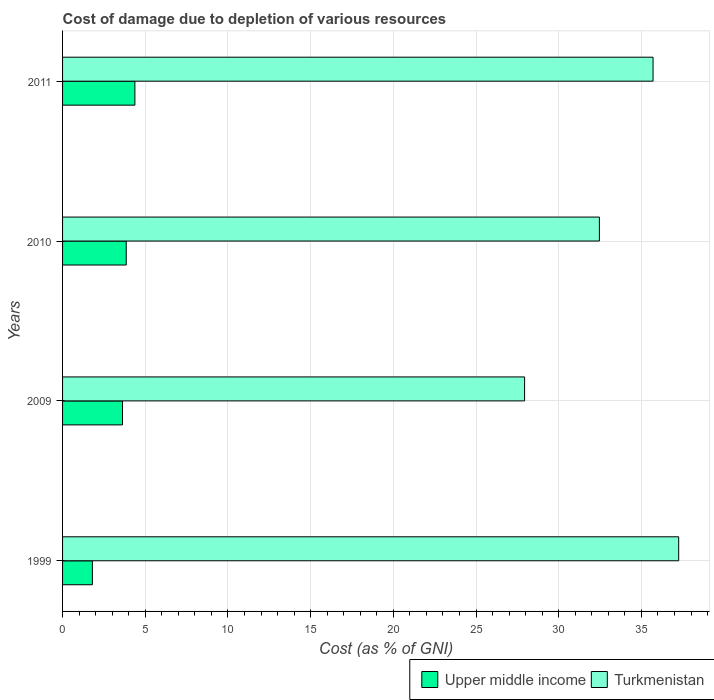How many different coloured bars are there?
Provide a short and direct response. 2. Are the number of bars on each tick of the Y-axis equal?
Give a very brief answer. Yes. How many bars are there on the 4th tick from the top?
Your answer should be very brief. 2. What is the label of the 1st group of bars from the top?
Your response must be concise. 2011. In how many cases, is the number of bars for a given year not equal to the number of legend labels?
Ensure brevity in your answer.  0. What is the cost of damage caused due to the depletion of various resources in Turkmenistan in 2011?
Keep it short and to the point. 35.7. Across all years, what is the maximum cost of damage caused due to the depletion of various resources in Upper middle income?
Provide a short and direct response. 4.37. Across all years, what is the minimum cost of damage caused due to the depletion of various resources in Upper middle income?
Make the answer very short. 1.8. In which year was the cost of damage caused due to the depletion of various resources in Upper middle income maximum?
Give a very brief answer. 2011. In which year was the cost of damage caused due to the depletion of various resources in Upper middle income minimum?
Keep it short and to the point. 1999. What is the total cost of damage caused due to the depletion of various resources in Upper middle income in the graph?
Offer a terse response. 13.65. What is the difference between the cost of damage caused due to the depletion of various resources in Turkmenistan in 2010 and that in 2011?
Provide a short and direct response. -3.24. What is the difference between the cost of damage caused due to the depletion of various resources in Turkmenistan in 2011 and the cost of damage caused due to the depletion of various resources in Upper middle income in 1999?
Ensure brevity in your answer.  33.9. What is the average cost of damage caused due to the depletion of various resources in Upper middle income per year?
Provide a succinct answer. 3.41. In the year 1999, what is the difference between the cost of damage caused due to the depletion of various resources in Turkmenistan and cost of damage caused due to the depletion of various resources in Upper middle income?
Offer a terse response. 35.45. In how many years, is the cost of damage caused due to the depletion of various resources in Upper middle income greater than 3 %?
Give a very brief answer. 3. What is the ratio of the cost of damage caused due to the depletion of various resources in Turkmenistan in 1999 to that in 2010?
Your response must be concise. 1.15. Is the cost of damage caused due to the depletion of various resources in Upper middle income in 2009 less than that in 2011?
Offer a very short reply. Yes. Is the difference between the cost of damage caused due to the depletion of various resources in Turkmenistan in 2009 and 2010 greater than the difference between the cost of damage caused due to the depletion of various resources in Upper middle income in 2009 and 2010?
Provide a short and direct response. No. What is the difference between the highest and the second highest cost of damage caused due to the depletion of various resources in Upper middle income?
Offer a very short reply. 0.52. What is the difference between the highest and the lowest cost of damage caused due to the depletion of various resources in Upper middle income?
Your answer should be very brief. 2.57. Is the sum of the cost of damage caused due to the depletion of various resources in Turkmenistan in 1999 and 2011 greater than the maximum cost of damage caused due to the depletion of various resources in Upper middle income across all years?
Make the answer very short. Yes. What does the 2nd bar from the top in 2009 represents?
Offer a very short reply. Upper middle income. What does the 1st bar from the bottom in 2009 represents?
Your response must be concise. Upper middle income. Are all the bars in the graph horizontal?
Make the answer very short. Yes. How many years are there in the graph?
Your response must be concise. 4. What is the difference between two consecutive major ticks on the X-axis?
Your answer should be very brief. 5. Does the graph contain grids?
Make the answer very short. Yes. Where does the legend appear in the graph?
Provide a short and direct response. Bottom right. How many legend labels are there?
Provide a succinct answer. 2. How are the legend labels stacked?
Offer a terse response. Horizontal. What is the title of the graph?
Your answer should be compact. Cost of damage due to depletion of various resources. Does "Angola" appear as one of the legend labels in the graph?
Provide a succinct answer. No. What is the label or title of the X-axis?
Your answer should be very brief. Cost (as % of GNI). What is the label or title of the Y-axis?
Your answer should be very brief. Years. What is the Cost (as % of GNI) of Upper middle income in 1999?
Ensure brevity in your answer.  1.8. What is the Cost (as % of GNI) of Turkmenistan in 1999?
Your answer should be compact. 37.25. What is the Cost (as % of GNI) in Upper middle income in 2009?
Your answer should be compact. 3.62. What is the Cost (as % of GNI) of Turkmenistan in 2009?
Your answer should be compact. 27.94. What is the Cost (as % of GNI) in Upper middle income in 2010?
Your response must be concise. 3.85. What is the Cost (as % of GNI) in Turkmenistan in 2010?
Give a very brief answer. 32.46. What is the Cost (as % of GNI) in Upper middle income in 2011?
Offer a terse response. 4.37. What is the Cost (as % of GNI) in Turkmenistan in 2011?
Your answer should be very brief. 35.7. Across all years, what is the maximum Cost (as % of GNI) of Upper middle income?
Give a very brief answer. 4.37. Across all years, what is the maximum Cost (as % of GNI) in Turkmenistan?
Provide a short and direct response. 37.25. Across all years, what is the minimum Cost (as % of GNI) in Upper middle income?
Your response must be concise. 1.8. Across all years, what is the minimum Cost (as % of GNI) of Turkmenistan?
Make the answer very short. 27.94. What is the total Cost (as % of GNI) in Upper middle income in the graph?
Make the answer very short. 13.65. What is the total Cost (as % of GNI) of Turkmenistan in the graph?
Your response must be concise. 133.35. What is the difference between the Cost (as % of GNI) of Upper middle income in 1999 and that in 2009?
Offer a very short reply. -1.82. What is the difference between the Cost (as % of GNI) in Turkmenistan in 1999 and that in 2009?
Your response must be concise. 9.32. What is the difference between the Cost (as % of GNI) in Upper middle income in 1999 and that in 2010?
Ensure brevity in your answer.  -2.05. What is the difference between the Cost (as % of GNI) of Turkmenistan in 1999 and that in 2010?
Your response must be concise. 4.79. What is the difference between the Cost (as % of GNI) of Upper middle income in 1999 and that in 2011?
Your answer should be compact. -2.57. What is the difference between the Cost (as % of GNI) of Turkmenistan in 1999 and that in 2011?
Give a very brief answer. 1.55. What is the difference between the Cost (as % of GNI) of Upper middle income in 2009 and that in 2010?
Make the answer very short. -0.22. What is the difference between the Cost (as % of GNI) in Turkmenistan in 2009 and that in 2010?
Make the answer very short. -4.52. What is the difference between the Cost (as % of GNI) in Upper middle income in 2009 and that in 2011?
Provide a short and direct response. -0.75. What is the difference between the Cost (as % of GNI) of Turkmenistan in 2009 and that in 2011?
Your response must be concise. -7.77. What is the difference between the Cost (as % of GNI) in Upper middle income in 2010 and that in 2011?
Your answer should be compact. -0.52. What is the difference between the Cost (as % of GNI) in Turkmenistan in 2010 and that in 2011?
Give a very brief answer. -3.24. What is the difference between the Cost (as % of GNI) in Upper middle income in 1999 and the Cost (as % of GNI) in Turkmenistan in 2009?
Make the answer very short. -26.13. What is the difference between the Cost (as % of GNI) in Upper middle income in 1999 and the Cost (as % of GNI) in Turkmenistan in 2010?
Ensure brevity in your answer.  -30.66. What is the difference between the Cost (as % of GNI) of Upper middle income in 1999 and the Cost (as % of GNI) of Turkmenistan in 2011?
Provide a succinct answer. -33.9. What is the difference between the Cost (as % of GNI) of Upper middle income in 2009 and the Cost (as % of GNI) of Turkmenistan in 2010?
Offer a very short reply. -28.83. What is the difference between the Cost (as % of GNI) in Upper middle income in 2009 and the Cost (as % of GNI) in Turkmenistan in 2011?
Your response must be concise. -32.08. What is the difference between the Cost (as % of GNI) in Upper middle income in 2010 and the Cost (as % of GNI) in Turkmenistan in 2011?
Provide a short and direct response. -31.86. What is the average Cost (as % of GNI) in Upper middle income per year?
Make the answer very short. 3.41. What is the average Cost (as % of GNI) in Turkmenistan per year?
Your response must be concise. 33.34. In the year 1999, what is the difference between the Cost (as % of GNI) in Upper middle income and Cost (as % of GNI) in Turkmenistan?
Your answer should be very brief. -35.45. In the year 2009, what is the difference between the Cost (as % of GNI) of Upper middle income and Cost (as % of GNI) of Turkmenistan?
Make the answer very short. -24.31. In the year 2010, what is the difference between the Cost (as % of GNI) of Upper middle income and Cost (as % of GNI) of Turkmenistan?
Your response must be concise. -28.61. In the year 2011, what is the difference between the Cost (as % of GNI) of Upper middle income and Cost (as % of GNI) of Turkmenistan?
Your answer should be compact. -31.33. What is the ratio of the Cost (as % of GNI) in Upper middle income in 1999 to that in 2009?
Provide a succinct answer. 0.5. What is the ratio of the Cost (as % of GNI) of Turkmenistan in 1999 to that in 2009?
Your response must be concise. 1.33. What is the ratio of the Cost (as % of GNI) of Upper middle income in 1999 to that in 2010?
Ensure brevity in your answer.  0.47. What is the ratio of the Cost (as % of GNI) of Turkmenistan in 1999 to that in 2010?
Your response must be concise. 1.15. What is the ratio of the Cost (as % of GNI) in Upper middle income in 1999 to that in 2011?
Provide a succinct answer. 0.41. What is the ratio of the Cost (as % of GNI) in Turkmenistan in 1999 to that in 2011?
Make the answer very short. 1.04. What is the ratio of the Cost (as % of GNI) of Upper middle income in 2009 to that in 2010?
Offer a very short reply. 0.94. What is the ratio of the Cost (as % of GNI) in Turkmenistan in 2009 to that in 2010?
Your response must be concise. 0.86. What is the ratio of the Cost (as % of GNI) of Upper middle income in 2009 to that in 2011?
Give a very brief answer. 0.83. What is the ratio of the Cost (as % of GNI) in Turkmenistan in 2009 to that in 2011?
Ensure brevity in your answer.  0.78. What is the ratio of the Cost (as % of GNI) in Upper middle income in 2010 to that in 2011?
Provide a succinct answer. 0.88. What is the difference between the highest and the second highest Cost (as % of GNI) in Upper middle income?
Provide a succinct answer. 0.52. What is the difference between the highest and the second highest Cost (as % of GNI) in Turkmenistan?
Provide a short and direct response. 1.55. What is the difference between the highest and the lowest Cost (as % of GNI) in Upper middle income?
Your answer should be compact. 2.57. What is the difference between the highest and the lowest Cost (as % of GNI) of Turkmenistan?
Offer a very short reply. 9.32. 